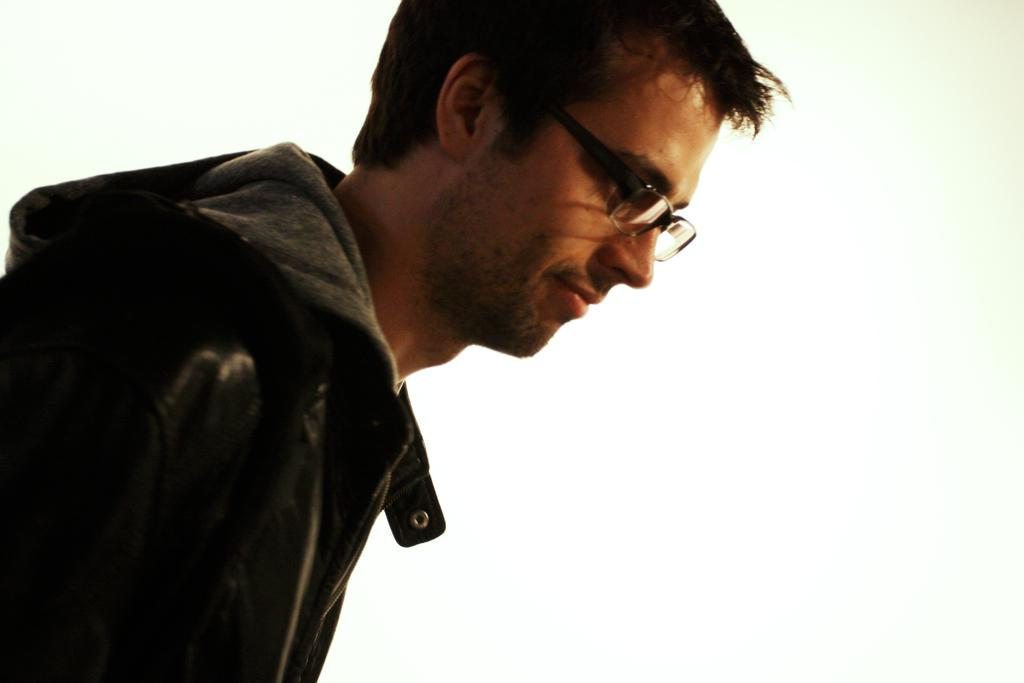Who or what is the main subject in the image? There is a person in the image. What is the person doing or where are they located in the image? The person is present over a place. What type of clothing is the person wearing? The person is wearing a jacket. Are there any accessories visible on the person? The person is wearing spectacles. What is the person's facial expression in the image? The person is smiling. What type of kettle is visible in the image? There is no kettle present in the image. 